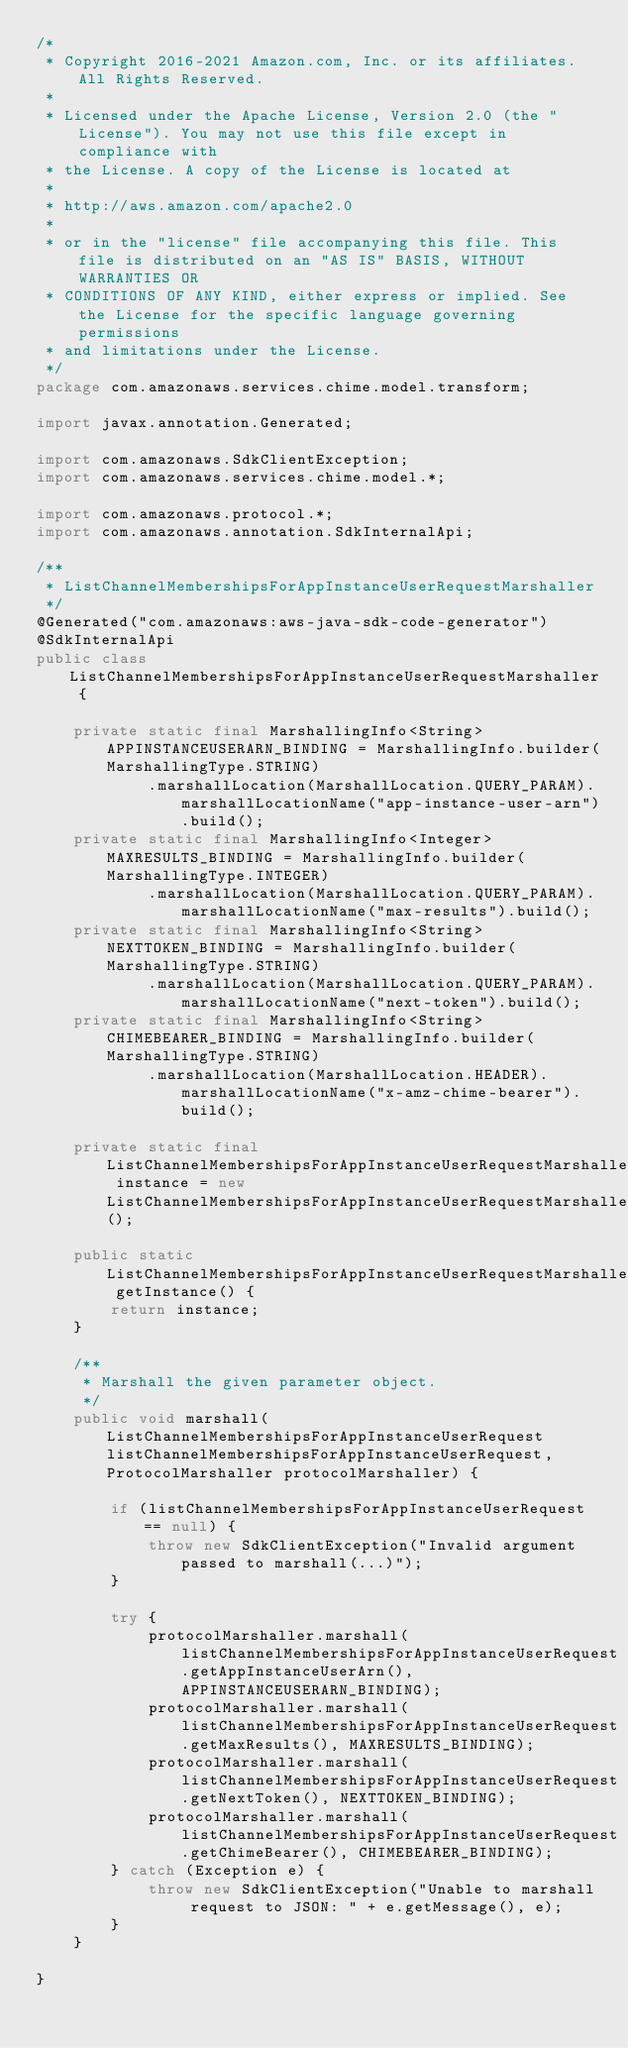<code> <loc_0><loc_0><loc_500><loc_500><_Java_>/*
 * Copyright 2016-2021 Amazon.com, Inc. or its affiliates. All Rights Reserved.
 * 
 * Licensed under the Apache License, Version 2.0 (the "License"). You may not use this file except in compliance with
 * the License. A copy of the License is located at
 * 
 * http://aws.amazon.com/apache2.0
 * 
 * or in the "license" file accompanying this file. This file is distributed on an "AS IS" BASIS, WITHOUT WARRANTIES OR
 * CONDITIONS OF ANY KIND, either express or implied. See the License for the specific language governing permissions
 * and limitations under the License.
 */
package com.amazonaws.services.chime.model.transform;

import javax.annotation.Generated;

import com.amazonaws.SdkClientException;
import com.amazonaws.services.chime.model.*;

import com.amazonaws.protocol.*;
import com.amazonaws.annotation.SdkInternalApi;

/**
 * ListChannelMembershipsForAppInstanceUserRequestMarshaller
 */
@Generated("com.amazonaws:aws-java-sdk-code-generator")
@SdkInternalApi
public class ListChannelMembershipsForAppInstanceUserRequestMarshaller {

    private static final MarshallingInfo<String> APPINSTANCEUSERARN_BINDING = MarshallingInfo.builder(MarshallingType.STRING)
            .marshallLocation(MarshallLocation.QUERY_PARAM).marshallLocationName("app-instance-user-arn").build();
    private static final MarshallingInfo<Integer> MAXRESULTS_BINDING = MarshallingInfo.builder(MarshallingType.INTEGER)
            .marshallLocation(MarshallLocation.QUERY_PARAM).marshallLocationName("max-results").build();
    private static final MarshallingInfo<String> NEXTTOKEN_BINDING = MarshallingInfo.builder(MarshallingType.STRING)
            .marshallLocation(MarshallLocation.QUERY_PARAM).marshallLocationName("next-token").build();
    private static final MarshallingInfo<String> CHIMEBEARER_BINDING = MarshallingInfo.builder(MarshallingType.STRING)
            .marshallLocation(MarshallLocation.HEADER).marshallLocationName("x-amz-chime-bearer").build();

    private static final ListChannelMembershipsForAppInstanceUserRequestMarshaller instance = new ListChannelMembershipsForAppInstanceUserRequestMarshaller();

    public static ListChannelMembershipsForAppInstanceUserRequestMarshaller getInstance() {
        return instance;
    }

    /**
     * Marshall the given parameter object.
     */
    public void marshall(ListChannelMembershipsForAppInstanceUserRequest listChannelMembershipsForAppInstanceUserRequest, ProtocolMarshaller protocolMarshaller) {

        if (listChannelMembershipsForAppInstanceUserRequest == null) {
            throw new SdkClientException("Invalid argument passed to marshall(...)");
        }

        try {
            protocolMarshaller.marshall(listChannelMembershipsForAppInstanceUserRequest.getAppInstanceUserArn(), APPINSTANCEUSERARN_BINDING);
            protocolMarshaller.marshall(listChannelMembershipsForAppInstanceUserRequest.getMaxResults(), MAXRESULTS_BINDING);
            protocolMarshaller.marshall(listChannelMembershipsForAppInstanceUserRequest.getNextToken(), NEXTTOKEN_BINDING);
            protocolMarshaller.marshall(listChannelMembershipsForAppInstanceUserRequest.getChimeBearer(), CHIMEBEARER_BINDING);
        } catch (Exception e) {
            throw new SdkClientException("Unable to marshall request to JSON: " + e.getMessage(), e);
        }
    }

}
</code> 